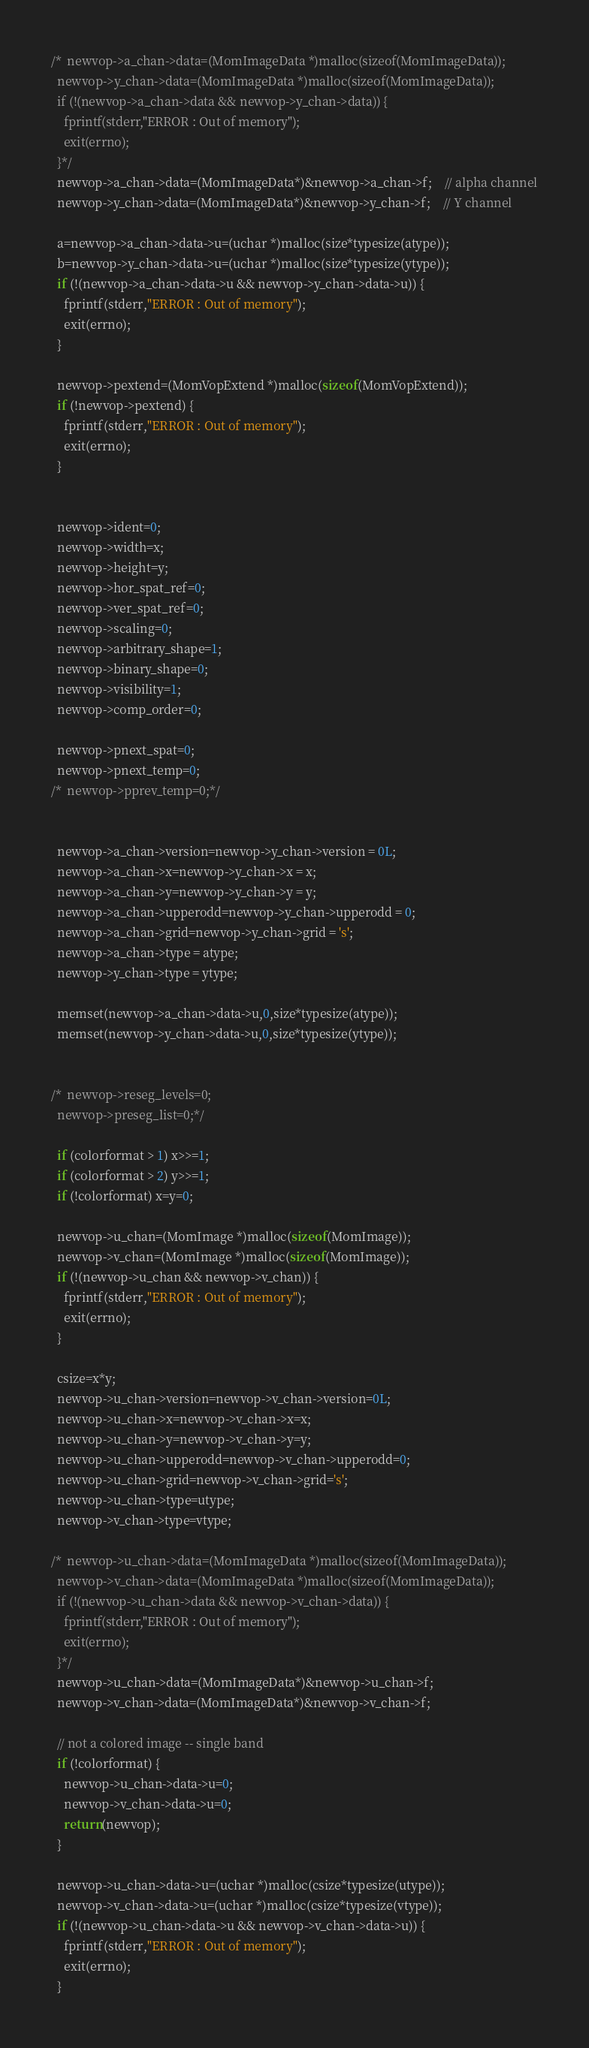<code> <loc_0><loc_0><loc_500><loc_500><_C_>/*  newvop->a_chan->data=(MomImageData *)malloc(sizeof(MomImageData));
  newvop->y_chan->data=(MomImageData *)malloc(sizeof(MomImageData));
  if (!(newvop->a_chan->data && newvop->y_chan->data)) {
    fprintf(stderr,"ERROR : Out of memory");
    exit(errno);
  }*/
  newvop->a_chan->data=(MomImageData*)&newvop->a_chan->f;	// alpha channel
  newvop->y_chan->data=(MomImageData*)&newvop->y_chan->f;	// Y channel

  a=newvop->a_chan->data->u=(uchar *)malloc(size*typesize(atype));
  b=newvop->y_chan->data->u=(uchar *)malloc(size*typesize(ytype));
  if (!(newvop->a_chan->data->u && newvop->y_chan->data->u)) {
    fprintf(stderr,"ERROR : Out of memory");
    exit(errno);
  }

  newvop->pextend=(MomVopExtend *)malloc(sizeof(MomVopExtend));
  if (!newvop->pextend) {
    fprintf(stderr,"ERROR : Out of memory");
    exit(errno);
  }


  newvop->ident=0;
  newvop->width=x;
  newvop->height=y;
  newvop->hor_spat_ref=0;
  newvop->ver_spat_ref=0;
  newvop->scaling=0;
  newvop->arbitrary_shape=1;
  newvop->binary_shape=0;
  newvop->visibility=1;
  newvop->comp_order=0;

  newvop->pnext_spat=0;
  newvop->pnext_temp=0;
/*  newvop->pprev_temp=0;*/


  newvop->a_chan->version=newvop->y_chan->version = 0L;
  newvop->a_chan->x=newvop->y_chan->x = x;
  newvop->a_chan->y=newvop->y_chan->y = y;
  newvop->a_chan->upperodd=newvop->y_chan->upperodd = 0;
  newvop->a_chan->grid=newvop->y_chan->grid = 's';
  newvop->a_chan->type = atype;
  newvop->y_chan->type = ytype;

  memset(newvop->a_chan->data->u,0,size*typesize(atype));
  memset(newvop->y_chan->data->u,0,size*typesize(ytype));


/*  newvop->reseg_levels=0;
  newvop->preseg_list=0;*/

  if (colorformat > 1) x>>=1;
  if (colorformat > 2) y>>=1;
  if (!colorformat) x=y=0;

  newvop->u_chan=(MomImage *)malloc(sizeof(MomImage));
  newvop->v_chan=(MomImage *)malloc(sizeof(MomImage));
  if (!(newvop->u_chan && newvop->v_chan)) {
    fprintf(stderr,"ERROR : Out of memory");
    exit(errno);
  }

  csize=x*y;
  newvop->u_chan->version=newvop->v_chan->version=0L;
  newvop->u_chan->x=newvop->v_chan->x=x;
  newvop->u_chan->y=newvop->v_chan->y=y;
  newvop->u_chan->upperodd=newvop->v_chan->upperodd=0;
  newvop->u_chan->grid=newvop->v_chan->grid='s';
  newvop->u_chan->type=utype;
  newvop->v_chan->type=vtype;

/*  newvop->u_chan->data=(MomImageData *)malloc(sizeof(MomImageData));
  newvop->v_chan->data=(MomImageData *)malloc(sizeof(MomImageData));
  if (!(newvop->u_chan->data && newvop->v_chan->data)) {
    fprintf(stderr,"ERROR : Out of memory");
    exit(errno);
  }*/
  newvop->u_chan->data=(MomImageData*)&newvop->u_chan->f;
  newvop->v_chan->data=(MomImageData*)&newvop->v_chan->f;

  // not a colored image -- single band
  if (!colorformat) {
    newvop->u_chan->data->u=0;
    newvop->v_chan->data->u=0;
    return(newvop);
  }

  newvop->u_chan->data->u=(uchar *)malloc(csize*typesize(utype));
  newvop->v_chan->data->u=(uchar *)malloc(csize*typesize(vtype));
  if (!(newvop->u_chan->data->u && newvop->v_chan->data->u)) {
    fprintf(stderr,"ERROR : Out of memory");
    exit(errno);
  }
</code> 